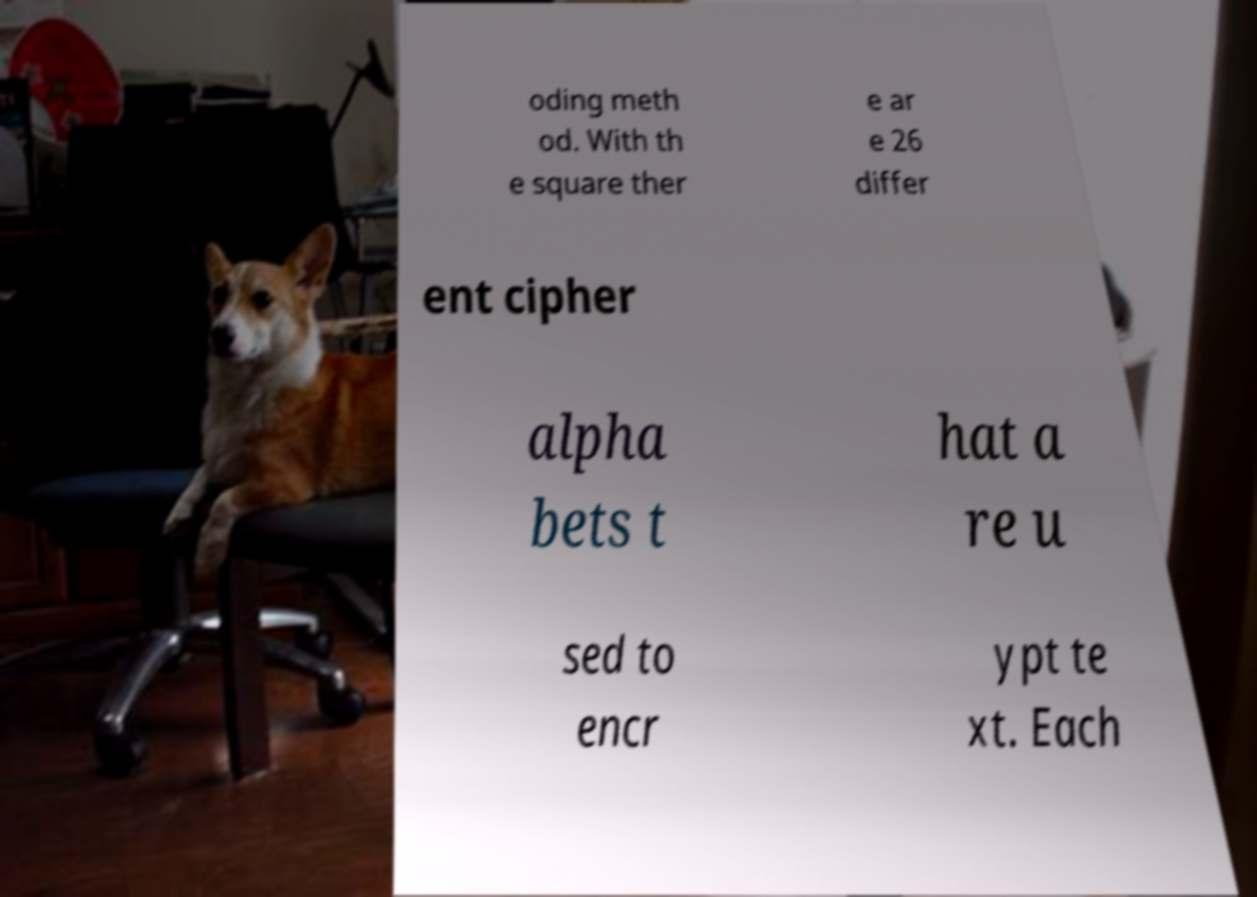What messages or text are displayed in this image? I need them in a readable, typed format. oding meth od. With th e square ther e ar e 26 differ ent cipher alpha bets t hat a re u sed to encr ypt te xt. Each 